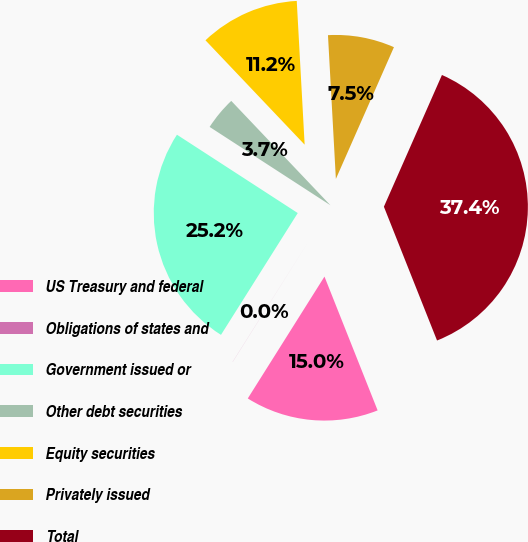Convert chart to OTSL. <chart><loc_0><loc_0><loc_500><loc_500><pie_chart><fcel>US Treasury and federal<fcel>Obligations of states and<fcel>Government issued or<fcel>Other debt securities<fcel>Equity securities<fcel>Privately issued<fcel>Total<nl><fcel>14.96%<fcel>0.01%<fcel>25.21%<fcel>3.75%<fcel>11.22%<fcel>7.48%<fcel>37.38%<nl></chart> 